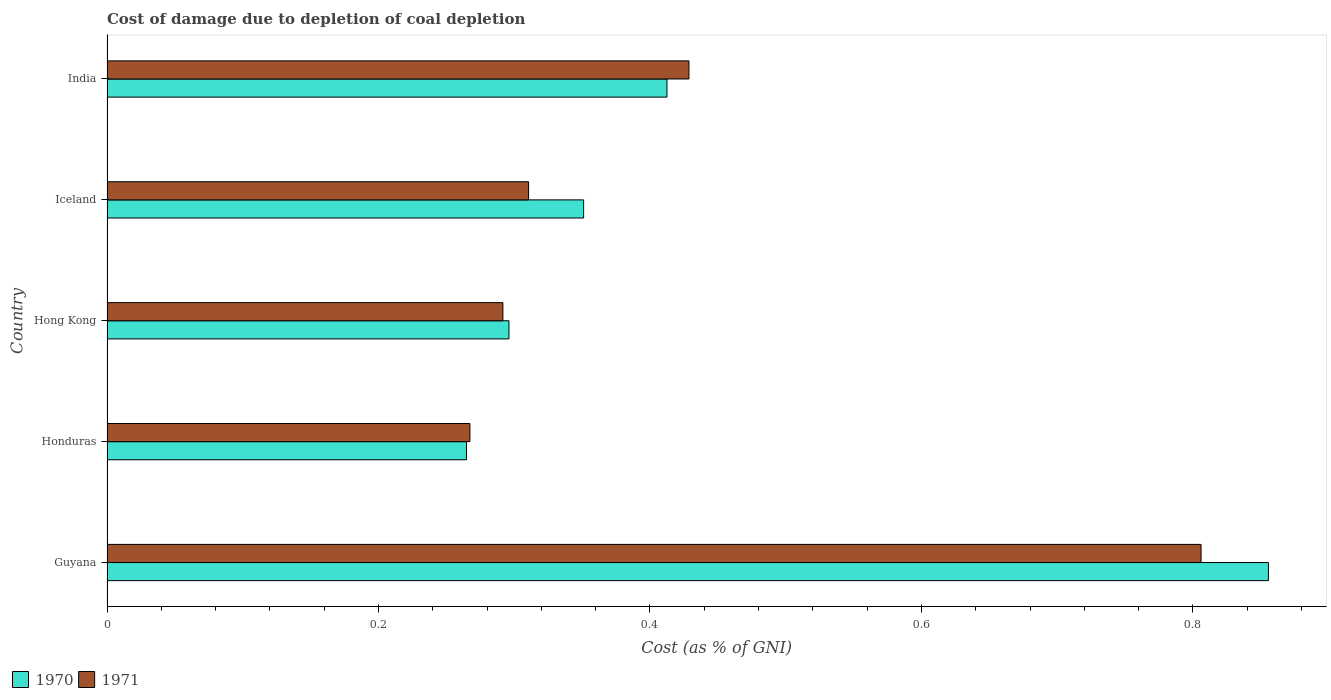How many different coloured bars are there?
Offer a terse response. 2. How many groups of bars are there?
Give a very brief answer. 5. Are the number of bars per tick equal to the number of legend labels?
Provide a short and direct response. Yes. Are the number of bars on each tick of the Y-axis equal?
Provide a short and direct response. Yes. How many bars are there on the 2nd tick from the top?
Your response must be concise. 2. What is the cost of damage caused due to coal depletion in 1970 in India?
Make the answer very short. 0.41. Across all countries, what is the maximum cost of damage caused due to coal depletion in 1971?
Your response must be concise. 0.81. Across all countries, what is the minimum cost of damage caused due to coal depletion in 1970?
Provide a short and direct response. 0.26. In which country was the cost of damage caused due to coal depletion in 1970 maximum?
Ensure brevity in your answer.  Guyana. In which country was the cost of damage caused due to coal depletion in 1971 minimum?
Offer a very short reply. Honduras. What is the total cost of damage caused due to coal depletion in 1971 in the graph?
Give a very brief answer. 2.1. What is the difference between the cost of damage caused due to coal depletion in 1971 in Guyana and that in Honduras?
Give a very brief answer. 0.54. What is the difference between the cost of damage caused due to coal depletion in 1970 in Guyana and the cost of damage caused due to coal depletion in 1971 in Hong Kong?
Make the answer very short. 0.56. What is the average cost of damage caused due to coal depletion in 1971 per country?
Give a very brief answer. 0.42. What is the difference between the cost of damage caused due to coal depletion in 1971 and cost of damage caused due to coal depletion in 1970 in India?
Provide a succinct answer. 0.02. What is the ratio of the cost of damage caused due to coal depletion in 1970 in Iceland to that in India?
Provide a succinct answer. 0.85. Is the cost of damage caused due to coal depletion in 1971 in Iceland less than that in India?
Keep it short and to the point. Yes. Is the difference between the cost of damage caused due to coal depletion in 1971 in Guyana and Hong Kong greater than the difference between the cost of damage caused due to coal depletion in 1970 in Guyana and Hong Kong?
Keep it short and to the point. No. What is the difference between the highest and the second highest cost of damage caused due to coal depletion in 1971?
Your answer should be compact. 0.38. What is the difference between the highest and the lowest cost of damage caused due to coal depletion in 1971?
Give a very brief answer. 0.54. In how many countries, is the cost of damage caused due to coal depletion in 1971 greater than the average cost of damage caused due to coal depletion in 1971 taken over all countries?
Make the answer very short. 2. Is the sum of the cost of damage caused due to coal depletion in 1970 in Guyana and Iceland greater than the maximum cost of damage caused due to coal depletion in 1971 across all countries?
Provide a short and direct response. Yes. What does the 1st bar from the bottom in Guyana represents?
Provide a succinct answer. 1970. How many bars are there?
Your answer should be very brief. 10. Are all the bars in the graph horizontal?
Your answer should be compact. Yes. What is the difference between two consecutive major ticks on the X-axis?
Ensure brevity in your answer.  0.2. Are the values on the major ticks of X-axis written in scientific E-notation?
Make the answer very short. No. Does the graph contain any zero values?
Provide a short and direct response. No. Does the graph contain grids?
Your response must be concise. No. Where does the legend appear in the graph?
Give a very brief answer. Bottom left. How many legend labels are there?
Your answer should be very brief. 2. What is the title of the graph?
Your response must be concise. Cost of damage due to depletion of coal depletion. What is the label or title of the X-axis?
Your response must be concise. Cost (as % of GNI). What is the label or title of the Y-axis?
Keep it short and to the point. Country. What is the Cost (as % of GNI) in 1970 in Guyana?
Make the answer very short. 0.86. What is the Cost (as % of GNI) in 1971 in Guyana?
Your answer should be very brief. 0.81. What is the Cost (as % of GNI) of 1970 in Honduras?
Provide a short and direct response. 0.26. What is the Cost (as % of GNI) of 1971 in Honduras?
Provide a succinct answer. 0.27. What is the Cost (as % of GNI) in 1970 in Hong Kong?
Give a very brief answer. 0.3. What is the Cost (as % of GNI) of 1971 in Hong Kong?
Make the answer very short. 0.29. What is the Cost (as % of GNI) in 1970 in Iceland?
Provide a short and direct response. 0.35. What is the Cost (as % of GNI) of 1971 in Iceland?
Your answer should be very brief. 0.31. What is the Cost (as % of GNI) in 1970 in India?
Your answer should be compact. 0.41. What is the Cost (as % of GNI) in 1971 in India?
Ensure brevity in your answer.  0.43. Across all countries, what is the maximum Cost (as % of GNI) in 1970?
Offer a very short reply. 0.86. Across all countries, what is the maximum Cost (as % of GNI) of 1971?
Offer a terse response. 0.81. Across all countries, what is the minimum Cost (as % of GNI) in 1970?
Your answer should be compact. 0.26. Across all countries, what is the minimum Cost (as % of GNI) of 1971?
Give a very brief answer. 0.27. What is the total Cost (as % of GNI) in 1970 in the graph?
Make the answer very short. 2.18. What is the total Cost (as % of GNI) of 1971 in the graph?
Keep it short and to the point. 2.1. What is the difference between the Cost (as % of GNI) in 1970 in Guyana and that in Honduras?
Offer a terse response. 0.59. What is the difference between the Cost (as % of GNI) of 1971 in Guyana and that in Honduras?
Ensure brevity in your answer.  0.54. What is the difference between the Cost (as % of GNI) in 1970 in Guyana and that in Hong Kong?
Your answer should be compact. 0.56. What is the difference between the Cost (as % of GNI) of 1971 in Guyana and that in Hong Kong?
Offer a very short reply. 0.51. What is the difference between the Cost (as % of GNI) of 1970 in Guyana and that in Iceland?
Keep it short and to the point. 0.5. What is the difference between the Cost (as % of GNI) of 1971 in Guyana and that in Iceland?
Offer a very short reply. 0.5. What is the difference between the Cost (as % of GNI) of 1970 in Guyana and that in India?
Make the answer very short. 0.44. What is the difference between the Cost (as % of GNI) in 1971 in Guyana and that in India?
Make the answer very short. 0.38. What is the difference between the Cost (as % of GNI) of 1970 in Honduras and that in Hong Kong?
Offer a very short reply. -0.03. What is the difference between the Cost (as % of GNI) of 1971 in Honduras and that in Hong Kong?
Offer a terse response. -0.02. What is the difference between the Cost (as % of GNI) of 1970 in Honduras and that in Iceland?
Ensure brevity in your answer.  -0.09. What is the difference between the Cost (as % of GNI) of 1971 in Honduras and that in Iceland?
Make the answer very short. -0.04. What is the difference between the Cost (as % of GNI) in 1970 in Honduras and that in India?
Give a very brief answer. -0.15. What is the difference between the Cost (as % of GNI) in 1971 in Honduras and that in India?
Keep it short and to the point. -0.16. What is the difference between the Cost (as % of GNI) in 1970 in Hong Kong and that in Iceland?
Keep it short and to the point. -0.06. What is the difference between the Cost (as % of GNI) of 1971 in Hong Kong and that in Iceland?
Your response must be concise. -0.02. What is the difference between the Cost (as % of GNI) of 1970 in Hong Kong and that in India?
Your answer should be very brief. -0.12. What is the difference between the Cost (as % of GNI) of 1971 in Hong Kong and that in India?
Give a very brief answer. -0.14. What is the difference between the Cost (as % of GNI) in 1970 in Iceland and that in India?
Make the answer very short. -0.06. What is the difference between the Cost (as % of GNI) in 1971 in Iceland and that in India?
Your response must be concise. -0.12. What is the difference between the Cost (as % of GNI) in 1970 in Guyana and the Cost (as % of GNI) in 1971 in Honduras?
Ensure brevity in your answer.  0.59. What is the difference between the Cost (as % of GNI) of 1970 in Guyana and the Cost (as % of GNI) of 1971 in Hong Kong?
Your answer should be compact. 0.56. What is the difference between the Cost (as % of GNI) in 1970 in Guyana and the Cost (as % of GNI) in 1971 in Iceland?
Provide a succinct answer. 0.55. What is the difference between the Cost (as % of GNI) in 1970 in Guyana and the Cost (as % of GNI) in 1971 in India?
Your response must be concise. 0.43. What is the difference between the Cost (as % of GNI) of 1970 in Honduras and the Cost (as % of GNI) of 1971 in Hong Kong?
Keep it short and to the point. -0.03. What is the difference between the Cost (as % of GNI) in 1970 in Honduras and the Cost (as % of GNI) in 1971 in Iceland?
Your response must be concise. -0.05. What is the difference between the Cost (as % of GNI) of 1970 in Honduras and the Cost (as % of GNI) of 1971 in India?
Provide a short and direct response. -0.16. What is the difference between the Cost (as % of GNI) of 1970 in Hong Kong and the Cost (as % of GNI) of 1971 in Iceland?
Offer a very short reply. -0.01. What is the difference between the Cost (as % of GNI) of 1970 in Hong Kong and the Cost (as % of GNI) of 1971 in India?
Ensure brevity in your answer.  -0.13. What is the difference between the Cost (as % of GNI) of 1970 in Iceland and the Cost (as % of GNI) of 1971 in India?
Ensure brevity in your answer.  -0.08. What is the average Cost (as % of GNI) in 1970 per country?
Offer a terse response. 0.44. What is the average Cost (as % of GNI) in 1971 per country?
Provide a short and direct response. 0.42. What is the difference between the Cost (as % of GNI) of 1970 and Cost (as % of GNI) of 1971 in Guyana?
Provide a short and direct response. 0.05. What is the difference between the Cost (as % of GNI) of 1970 and Cost (as % of GNI) of 1971 in Honduras?
Keep it short and to the point. -0. What is the difference between the Cost (as % of GNI) of 1970 and Cost (as % of GNI) of 1971 in Hong Kong?
Offer a terse response. 0. What is the difference between the Cost (as % of GNI) in 1970 and Cost (as % of GNI) in 1971 in Iceland?
Make the answer very short. 0.04. What is the difference between the Cost (as % of GNI) of 1970 and Cost (as % of GNI) of 1971 in India?
Make the answer very short. -0.02. What is the ratio of the Cost (as % of GNI) of 1970 in Guyana to that in Honduras?
Provide a short and direct response. 3.23. What is the ratio of the Cost (as % of GNI) of 1971 in Guyana to that in Honduras?
Offer a very short reply. 3.01. What is the ratio of the Cost (as % of GNI) of 1970 in Guyana to that in Hong Kong?
Make the answer very short. 2.89. What is the ratio of the Cost (as % of GNI) in 1971 in Guyana to that in Hong Kong?
Offer a very short reply. 2.76. What is the ratio of the Cost (as % of GNI) of 1970 in Guyana to that in Iceland?
Your response must be concise. 2.44. What is the ratio of the Cost (as % of GNI) in 1971 in Guyana to that in Iceland?
Make the answer very short. 2.6. What is the ratio of the Cost (as % of GNI) of 1970 in Guyana to that in India?
Offer a terse response. 2.07. What is the ratio of the Cost (as % of GNI) in 1971 in Guyana to that in India?
Your response must be concise. 1.88. What is the ratio of the Cost (as % of GNI) in 1970 in Honduras to that in Hong Kong?
Ensure brevity in your answer.  0.89. What is the ratio of the Cost (as % of GNI) in 1970 in Honduras to that in Iceland?
Provide a succinct answer. 0.75. What is the ratio of the Cost (as % of GNI) of 1971 in Honduras to that in Iceland?
Your answer should be compact. 0.86. What is the ratio of the Cost (as % of GNI) of 1970 in Honduras to that in India?
Provide a succinct answer. 0.64. What is the ratio of the Cost (as % of GNI) of 1971 in Honduras to that in India?
Offer a very short reply. 0.62. What is the ratio of the Cost (as % of GNI) of 1970 in Hong Kong to that in Iceland?
Provide a short and direct response. 0.84. What is the ratio of the Cost (as % of GNI) in 1971 in Hong Kong to that in Iceland?
Your answer should be very brief. 0.94. What is the ratio of the Cost (as % of GNI) of 1970 in Hong Kong to that in India?
Keep it short and to the point. 0.72. What is the ratio of the Cost (as % of GNI) of 1971 in Hong Kong to that in India?
Keep it short and to the point. 0.68. What is the ratio of the Cost (as % of GNI) in 1970 in Iceland to that in India?
Your response must be concise. 0.85. What is the ratio of the Cost (as % of GNI) in 1971 in Iceland to that in India?
Make the answer very short. 0.72. What is the difference between the highest and the second highest Cost (as % of GNI) of 1970?
Your response must be concise. 0.44. What is the difference between the highest and the second highest Cost (as % of GNI) in 1971?
Offer a terse response. 0.38. What is the difference between the highest and the lowest Cost (as % of GNI) of 1970?
Your response must be concise. 0.59. What is the difference between the highest and the lowest Cost (as % of GNI) of 1971?
Offer a very short reply. 0.54. 